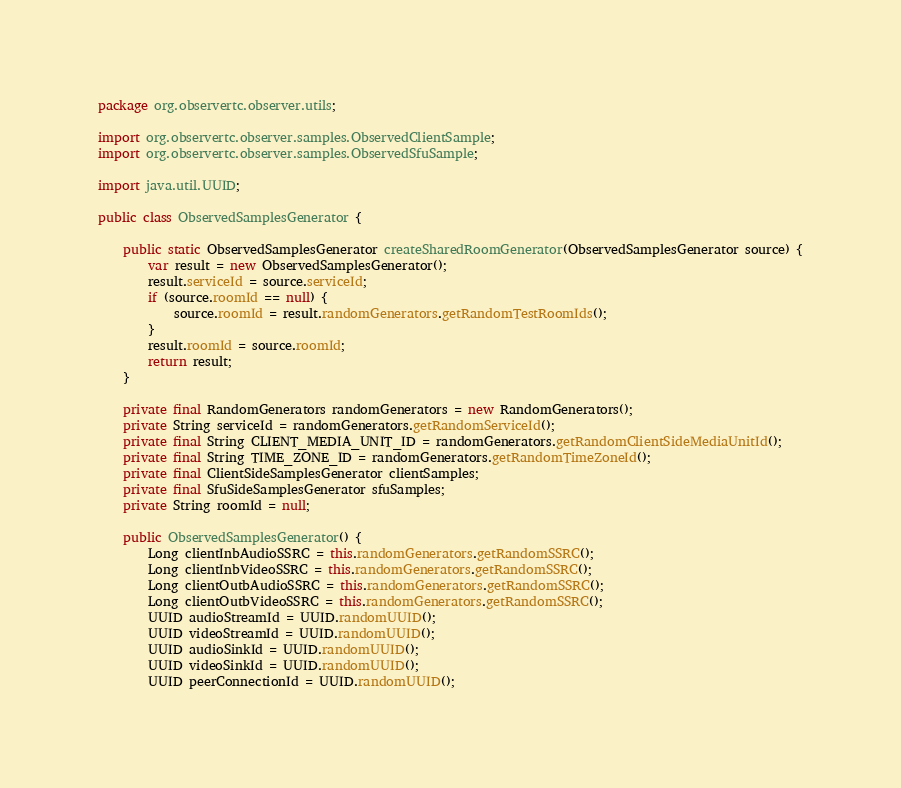<code> <loc_0><loc_0><loc_500><loc_500><_Java_>package org.observertc.observer.utils;

import org.observertc.observer.samples.ObservedClientSample;
import org.observertc.observer.samples.ObservedSfuSample;

import java.util.UUID;

public class ObservedSamplesGenerator {

    public static ObservedSamplesGenerator createSharedRoomGenerator(ObservedSamplesGenerator source) {
        var result = new ObservedSamplesGenerator();
        result.serviceId = source.serviceId;
        if (source.roomId == null) {
            source.roomId = result.randomGenerators.getRandomTestRoomIds();
        }
        result.roomId = source.roomId;
        return result;
    }

    private final RandomGenerators randomGenerators = new RandomGenerators();
    private String serviceId = randomGenerators.getRandomServiceId();
    private final String CLIENT_MEDIA_UNIT_ID = randomGenerators.getRandomClientSideMediaUnitId();
    private final String TIME_ZONE_ID = randomGenerators.getRandomTimeZoneId();
    private final ClientSideSamplesGenerator clientSamples;
    private final SfuSideSamplesGenerator sfuSamples;
    private String roomId = null;

    public ObservedSamplesGenerator() {
        Long clientInbAudioSSRC = this.randomGenerators.getRandomSSRC();
        Long clientInbVideoSSRC = this.randomGenerators.getRandomSSRC();
        Long clientOutbAudioSSRC = this.randomGenerators.getRandomSSRC();
        Long clientOutbVideoSSRC = this.randomGenerators.getRandomSSRC();
        UUID audioStreamId = UUID.randomUUID();
        UUID videoStreamId = UUID.randomUUID();
        UUID audioSinkId = UUID.randomUUID();
        UUID videoSinkId = UUID.randomUUID();
        UUID peerConnectionId = UUID.randomUUID();</code> 